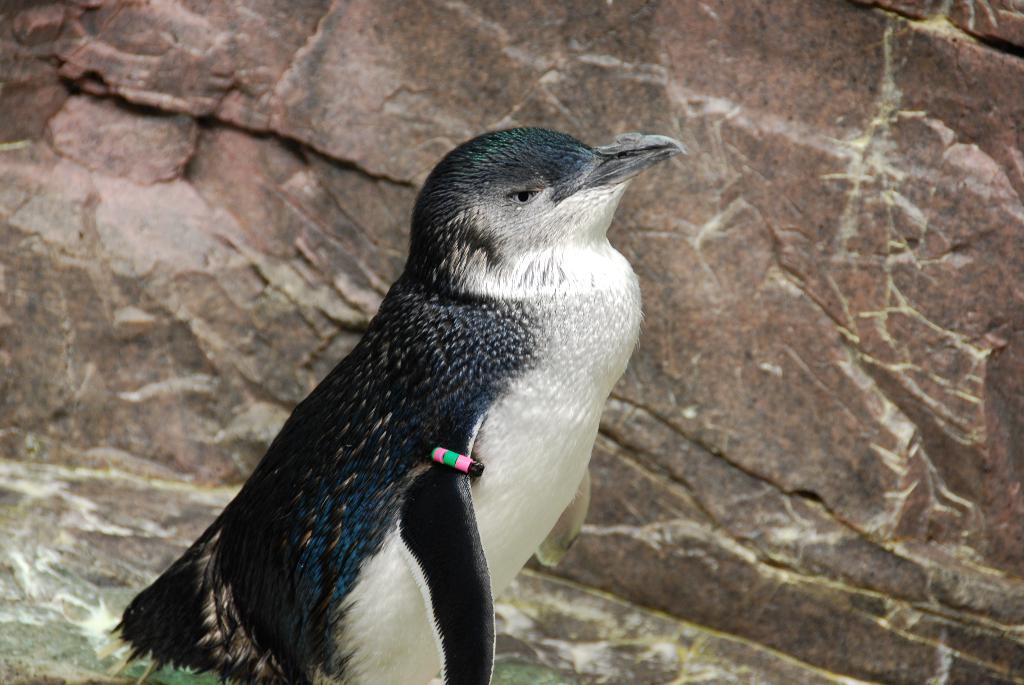What type of animal is in the image? There is a penguin in the image. What other object can be seen in the image? There is a rock in the image. What natural element is visible in the image? There is water visible in the image. What type of camera is being used to take the picture of the field in the image? There is no field or camera present in the image; it features a penguin and a rock near water. 